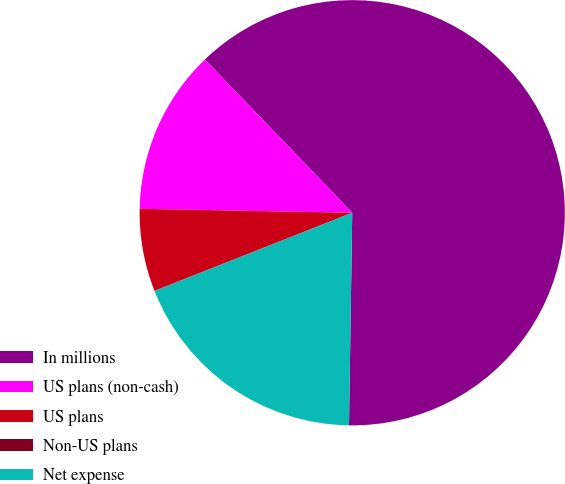Convert chart to OTSL. <chart><loc_0><loc_0><loc_500><loc_500><pie_chart><fcel>In millions<fcel>US plans (non-cash)<fcel>US plans<fcel>Non-US plans<fcel>Net expense<nl><fcel>62.43%<fcel>12.51%<fcel>6.27%<fcel>0.03%<fcel>18.75%<nl></chart> 